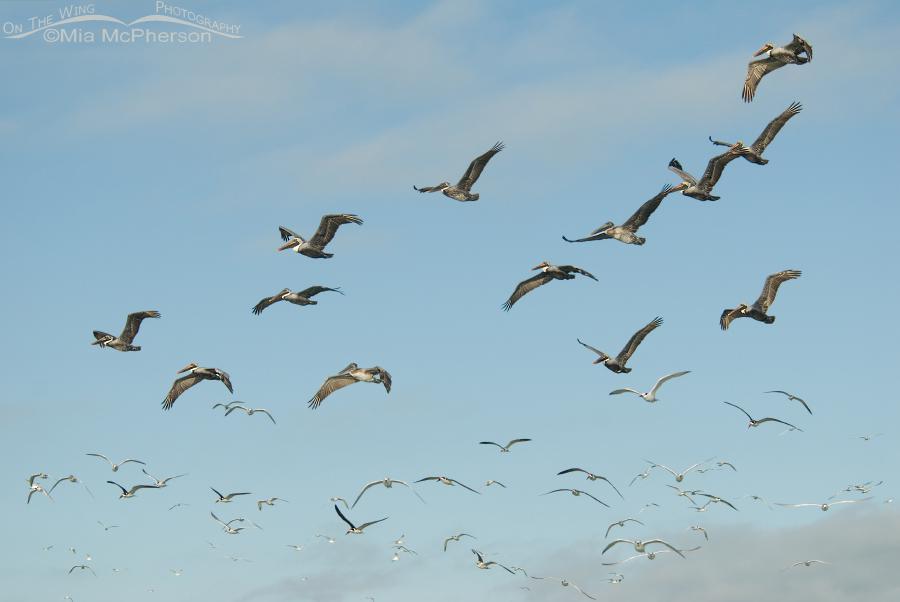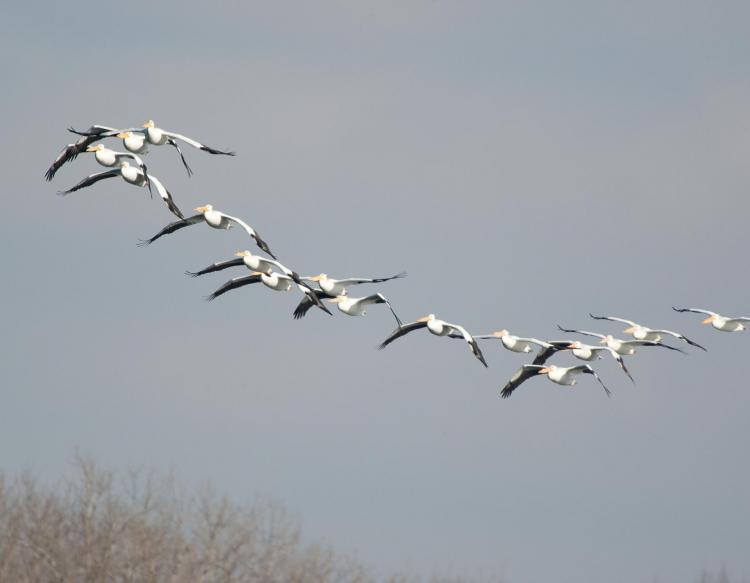The first image is the image on the left, the second image is the image on the right. Assess this claim about the two images: "A single bird is flying in the image on the left.". Correct or not? Answer yes or no. No. The first image is the image on the left, the second image is the image on the right. For the images displayed, is the sentence "A single dark pelican flying with outspread wings is in the foreground of the left image, and the right image shows at least 10 pelicans flying leftward." factually correct? Answer yes or no. No. 